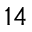Convert formula to latex. <formula><loc_0><loc_0><loc_500><loc_500>^ { 1 4 }</formula> 